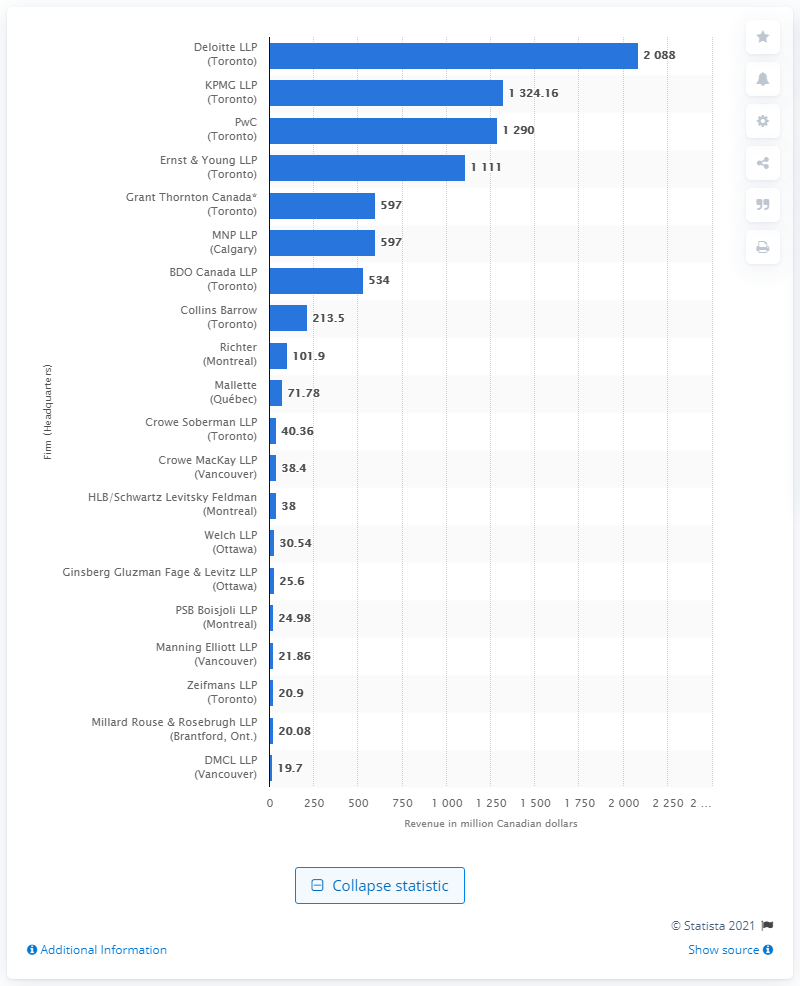Indicate a few pertinent items in this graphic. In 2015, Deloitte reported a revenue of 2088 million US dollars. 